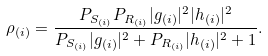Convert formula to latex. <formula><loc_0><loc_0><loc_500><loc_500>\rho _ { ( i ) } = \frac { P _ { S _ { ( i ) } } P _ { R _ { ( i ) } } | g _ { ( i ) } | ^ { 2 } | h _ { ( i ) } | ^ { 2 } } { P _ { S _ { ( i ) } } | g _ { ( i ) } | ^ { 2 } + P _ { R _ { ( i ) } } | h _ { ( i ) } | ^ { 2 } + 1 } .</formula> 